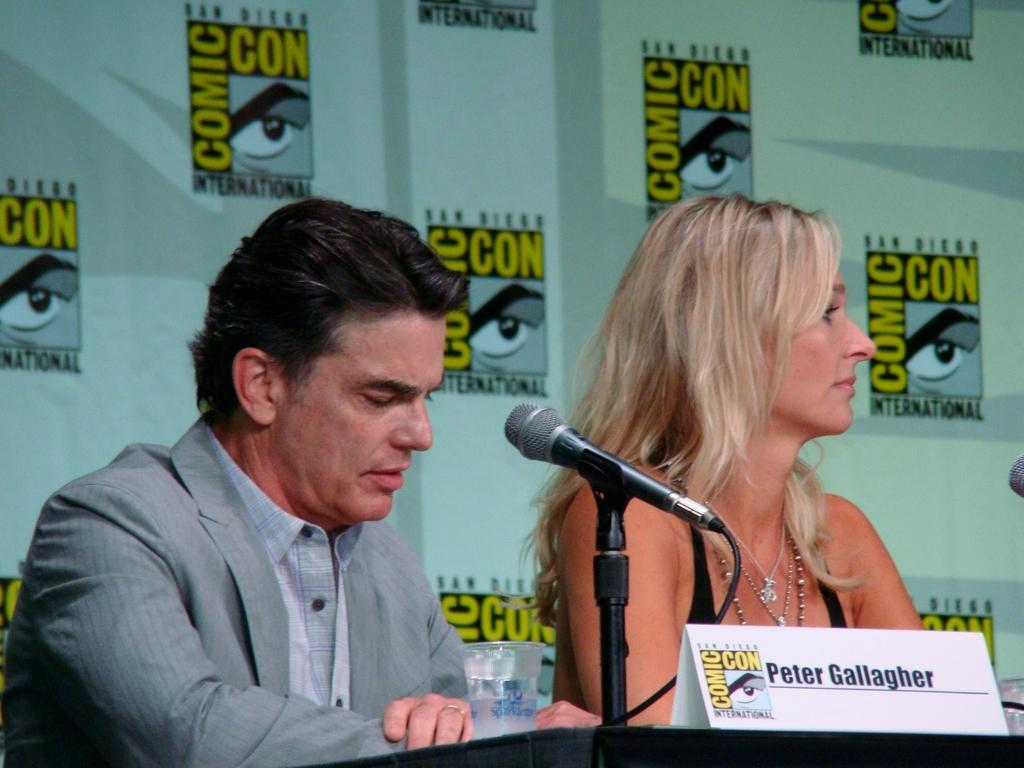Who can be seen in the foreground of the image? There is a man and a woman in the foreground of the image. What are they doing in the image? They are sitting in front of a table. What objects are on the table? There is a glass, a mic stand, and a board on the table. What can be seen in the background of the image? In the background, there is a banner wall. What is the smell of the mic stand in the image? There is no smell associated with the mic stand in the image, as it is an inanimate object. 